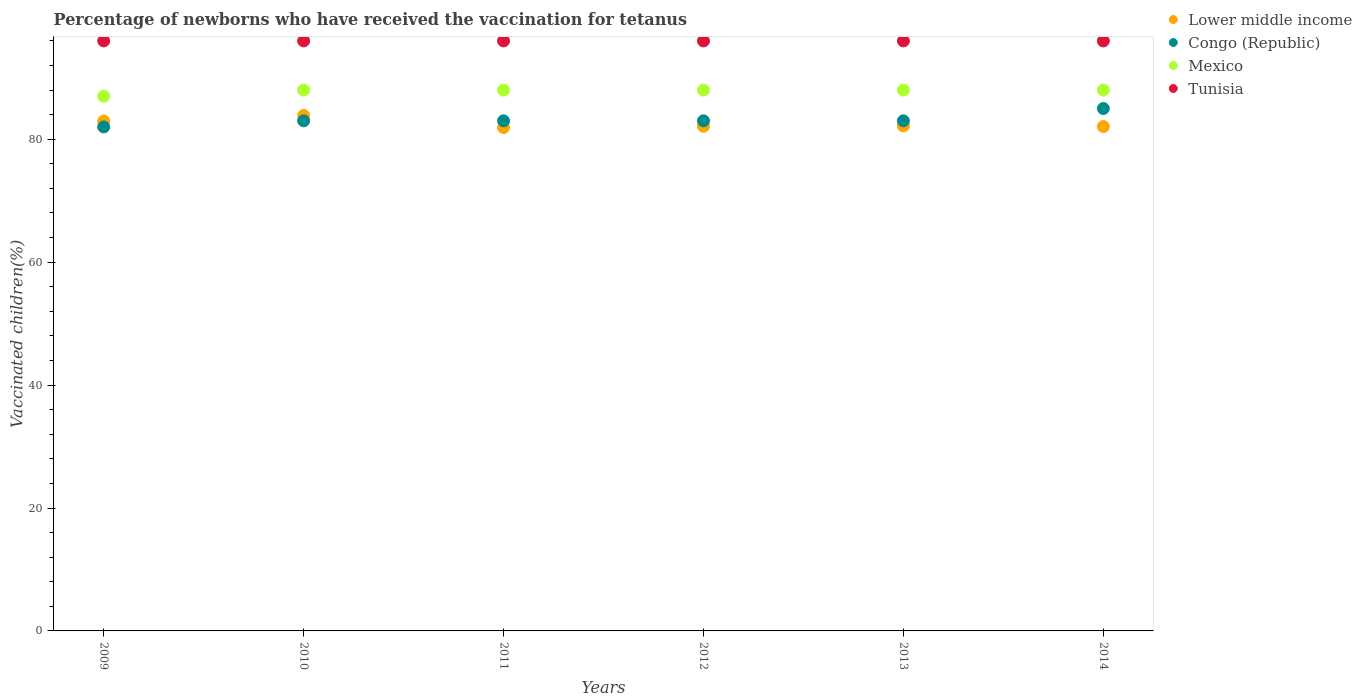What is the percentage of vaccinated children in Mexico in 2014?
Provide a short and direct response. 88. Across all years, what is the maximum percentage of vaccinated children in Mexico?
Ensure brevity in your answer.  88. In which year was the percentage of vaccinated children in Tunisia maximum?
Offer a very short reply. 2009. In which year was the percentage of vaccinated children in Mexico minimum?
Your answer should be very brief. 2009. What is the total percentage of vaccinated children in Congo (Republic) in the graph?
Offer a terse response. 499. What is the difference between the percentage of vaccinated children in Mexico in 2013 and that in 2014?
Provide a short and direct response. 0. What is the average percentage of vaccinated children in Congo (Republic) per year?
Make the answer very short. 83.17. In how many years, is the percentage of vaccinated children in Lower middle income greater than 92 %?
Offer a terse response. 0. What is the ratio of the percentage of vaccinated children in Lower middle income in 2010 to that in 2012?
Your response must be concise. 1.02. Is the difference between the percentage of vaccinated children in Tunisia in 2011 and 2013 greater than the difference between the percentage of vaccinated children in Congo (Republic) in 2011 and 2013?
Provide a short and direct response. No. In how many years, is the percentage of vaccinated children in Tunisia greater than the average percentage of vaccinated children in Tunisia taken over all years?
Your answer should be compact. 0. Is it the case that in every year, the sum of the percentage of vaccinated children in Mexico and percentage of vaccinated children in Congo (Republic)  is greater than the sum of percentage of vaccinated children in Tunisia and percentage of vaccinated children in Lower middle income?
Offer a terse response. Yes. Is it the case that in every year, the sum of the percentage of vaccinated children in Lower middle income and percentage of vaccinated children in Congo (Republic)  is greater than the percentage of vaccinated children in Mexico?
Keep it short and to the point. Yes. Does the percentage of vaccinated children in Congo (Republic) monotonically increase over the years?
Ensure brevity in your answer.  No. Is the percentage of vaccinated children in Mexico strictly less than the percentage of vaccinated children in Tunisia over the years?
Your answer should be compact. Yes. How many years are there in the graph?
Offer a very short reply. 6. How many legend labels are there?
Give a very brief answer. 4. What is the title of the graph?
Offer a very short reply. Percentage of newborns who have received the vaccination for tetanus. Does "Middle income" appear as one of the legend labels in the graph?
Offer a very short reply. No. What is the label or title of the Y-axis?
Make the answer very short. Vaccinated children(%). What is the Vaccinated children(%) in Lower middle income in 2009?
Keep it short and to the point. 82.96. What is the Vaccinated children(%) in Mexico in 2009?
Give a very brief answer. 87. What is the Vaccinated children(%) of Tunisia in 2009?
Provide a succinct answer. 96. What is the Vaccinated children(%) of Lower middle income in 2010?
Your response must be concise. 83.87. What is the Vaccinated children(%) in Congo (Republic) in 2010?
Offer a very short reply. 83. What is the Vaccinated children(%) of Tunisia in 2010?
Offer a terse response. 96. What is the Vaccinated children(%) in Lower middle income in 2011?
Keep it short and to the point. 81.9. What is the Vaccinated children(%) in Congo (Republic) in 2011?
Your response must be concise. 83. What is the Vaccinated children(%) in Mexico in 2011?
Ensure brevity in your answer.  88. What is the Vaccinated children(%) in Tunisia in 2011?
Make the answer very short. 96. What is the Vaccinated children(%) in Lower middle income in 2012?
Ensure brevity in your answer.  82.12. What is the Vaccinated children(%) in Congo (Republic) in 2012?
Your response must be concise. 83. What is the Vaccinated children(%) of Tunisia in 2012?
Offer a terse response. 96. What is the Vaccinated children(%) of Lower middle income in 2013?
Offer a terse response. 82.17. What is the Vaccinated children(%) in Congo (Republic) in 2013?
Offer a very short reply. 83. What is the Vaccinated children(%) in Mexico in 2013?
Your answer should be compact. 88. What is the Vaccinated children(%) of Tunisia in 2013?
Your response must be concise. 96. What is the Vaccinated children(%) of Lower middle income in 2014?
Give a very brief answer. 82.06. What is the Vaccinated children(%) of Congo (Republic) in 2014?
Provide a succinct answer. 85. What is the Vaccinated children(%) of Mexico in 2014?
Your response must be concise. 88. What is the Vaccinated children(%) in Tunisia in 2014?
Your answer should be compact. 96. Across all years, what is the maximum Vaccinated children(%) of Lower middle income?
Offer a terse response. 83.87. Across all years, what is the maximum Vaccinated children(%) of Mexico?
Make the answer very short. 88. Across all years, what is the maximum Vaccinated children(%) of Tunisia?
Offer a very short reply. 96. Across all years, what is the minimum Vaccinated children(%) in Lower middle income?
Offer a terse response. 81.9. Across all years, what is the minimum Vaccinated children(%) of Congo (Republic)?
Offer a terse response. 82. Across all years, what is the minimum Vaccinated children(%) in Mexico?
Offer a terse response. 87. Across all years, what is the minimum Vaccinated children(%) in Tunisia?
Your response must be concise. 96. What is the total Vaccinated children(%) in Lower middle income in the graph?
Keep it short and to the point. 495.07. What is the total Vaccinated children(%) in Congo (Republic) in the graph?
Keep it short and to the point. 499. What is the total Vaccinated children(%) in Mexico in the graph?
Give a very brief answer. 527. What is the total Vaccinated children(%) of Tunisia in the graph?
Your answer should be compact. 576. What is the difference between the Vaccinated children(%) of Lower middle income in 2009 and that in 2010?
Offer a terse response. -0.91. What is the difference between the Vaccinated children(%) in Mexico in 2009 and that in 2010?
Give a very brief answer. -1. What is the difference between the Vaccinated children(%) of Tunisia in 2009 and that in 2010?
Your answer should be compact. 0. What is the difference between the Vaccinated children(%) in Lower middle income in 2009 and that in 2011?
Your answer should be compact. 1.06. What is the difference between the Vaccinated children(%) of Lower middle income in 2009 and that in 2012?
Make the answer very short. 0.84. What is the difference between the Vaccinated children(%) of Congo (Republic) in 2009 and that in 2012?
Provide a succinct answer. -1. What is the difference between the Vaccinated children(%) of Tunisia in 2009 and that in 2012?
Provide a succinct answer. 0. What is the difference between the Vaccinated children(%) of Lower middle income in 2009 and that in 2013?
Offer a terse response. 0.79. What is the difference between the Vaccinated children(%) of Mexico in 2009 and that in 2013?
Give a very brief answer. -1. What is the difference between the Vaccinated children(%) in Tunisia in 2009 and that in 2013?
Make the answer very short. 0. What is the difference between the Vaccinated children(%) of Lower middle income in 2009 and that in 2014?
Provide a succinct answer. 0.89. What is the difference between the Vaccinated children(%) in Mexico in 2009 and that in 2014?
Keep it short and to the point. -1. What is the difference between the Vaccinated children(%) in Tunisia in 2009 and that in 2014?
Your answer should be compact. 0. What is the difference between the Vaccinated children(%) in Lower middle income in 2010 and that in 2011?
Your answer should be compact. 1.97. What is the difference between the Vaccinated children(%) in Tunisia in 2010 and that in 2011?
Your answer should be very brief. 0. What is the difference between the Vaccinated children(%) in Lower middle income in 2010 and that in 2012?
Your response must be concise. 1.75. What is the difference between the Vaccinated children(%) in Tunisia in 2010 and that in 2012?
Ensure brevity in your answer.  0. What is the difference between the Vaccinated children(%) in Lower middle income in 2010 and that in 2013?
Offer a terse response. 1.7. What is the difference between the Vaccinated children(%) in Congo (Republic) in 2010 and that in 2013?
Ensure brevity in your answer.  0. What is the difference between the Vaccinated children(%) of Tunisia in 2010 and that in 2013?
Give a very brief answer. 0. What is the difference between the Vaccinated children(%) of Lower middle income in 2010 and that in 2014?
Provide a short and direct response. 1.8. What is the difference between the Vaccinated children(%) of Congo (Republic) in 2010 and that in 2014?
Your response must be concise. -2. What is the difference between the Vaccinated children(%) in Lower middle income in 2011 and that in 2012?
Your response must be concise. -0.22. What is the difference between the Vaccinated children(%) of Tunisia in 2011 and that in 2012?
Keep it short and to the point. 0. What is the difference between the Vaccinated children(%) of Lower middle income in 2011 and that in 2013?
Keep it short and to the point. -0.27. What is the difference between the Vaccinated children(%) of Mexico in 2011 and that in 2013?
Your response must be concise. 0. What is the difference between the Vaccinated children(%) of Tunisia in 2011 and that in 2013?
Offer a terse response. 0. What is the difference between the Vaccinated children(%) in Lower middle income in 2011 and that in 2014?
Offer a very short reply. -0.16. What is the difference between the Vaccinated children(%) of Lower middle income in 2012 and that in 2013?
Ensure brevity in your answer.  -0.05. What is the difference between the Vaccinated children(%) in Mexico in 2012 and that in 2013?
Offer a very short reply. 0. What is the difference between the Vaccinated children(%) of Lower middle income in 2012 and that in 2014?
Offer a very short reply. 0.05. What is the difference between the Vaccinated children(%) of Congo (Republic) in 2012 and that in 2014?
Your answer should be compact. -2. What is the difference between the Vaccinated children(%) in Mexico in 2012 and that in 2014?
Ensure brevity in your answer.  0. What is the difference between the Vaccinated children(%) in Lower middle income in 2013 and that in 2014?
Offer a very short reply. 0.1. What is the difference between the Vaccinated children(%) of Tunisia in 2013 and that in 2014?
Make the answer very short. 0. What is the difference between the Vaccinated children(%) of Lower middle income in 2009 and the Vaccinated children(%) of Congo (Republic) in 2010?
Offer a terse response. -0.04. What is the difference between the Vaccinated children(%) in Lower middle income in 2009 and the Vaccinated children(%) in Mexico in 2010?
Make the answer very short. -5.04. What is the difference between the Vaccinated children(%) of Lower middle income in 2009 and the Vaccinated children(%) of Tunisia in 2010?
Provide a short and direct response. -13.04. What is the difference between the Vaccinated children(%) in Congo (Republic) in 2009 and the Vaccinated children(%) in Tunisia in 2010?
Offer a very short reply. -14. What is the difference between the Vaccinated children(%) of Mexico in 2009 and the Vaccinated children(%) of Tunisia in 2010?
Give a very brief answer. -9. What is the difference between the Vaccinated children(%) of Lower middle income in 2009 and the Vaccinated children(%) of Congo (Republic) in 2011?
Offer a very short reply. -0.04. What is the difference between the Vaccinated children(%) of Lower middle income in 2009 and the Vaccinated children(%) of Mexico in 2011?
Your response must be concise. -5.04. What is the difference between the Vaccinated children(%) in Lower middle income in 2009 and the Vaccinated children(%) in Tunisia in 2011?
Offer a very short reply. -13.04. What is the difference between the Vaccinated children(%) of Congo (Republic) in 2009 and the Vaccinated children(%) of Tunisia in 2011?
Your answer should be very brief. -14. What is the difference between the Vaccinated children(%) in Lower middle income in 2009 and the Vaccinated children(%) in Congo (Republic) in 2012?
Your response must be concise. -0.04. What is the difference between the Vaccinated children(%) in Lower middle income in 2009 and the Vaccinated children(%) in Mexico in 2012?
Offer a very short reply. -5.04. What is the difference between the Vaccinated children(%) in Lower middle income in 2009 and the Vaccinated children(%) in Tunisia in 2012?
Offer a very short reply. -13.04. What is the difference between the Vaccinated children(%) in Congo (Republic) in 2009 and the Vaccinated children(%) in Mexico in 2012?
Ensure brevity in your answer.  -6. What is the difference between the Vaccinated children(%) of Lower middle income in 2009 and the Vaccinated children(%) of Congo (Republic) in 2013?
Offer a very short reply. -0.04. What is the difference between the Vaccinated children(%) of Lower middle income in 2009 and the Vaccinated children(%) of Mexico in 2013?
Offer a terse response. -5.04. What is the difference between the Vaccinated children(%) in Lower middle income in 2009 and the Vaccinated children(%) in Tunisia in 2013?
Keep it short and to the point. -13.04. What is the difference between the Vaccinated children(%) of Mexico in 2009 and the Vaccinated children(%) of Tunisia in 2013?
Make the answer very short. -9. What is the difference between the Vaccinated children(%) of Lower middle income in 2009 and the Vaccinated children(%) of Congo (Republic) in 2014?
Offer a very short reply. -2.04. What is the difference between the Vaccinated children(%) of Lower middle income in 2009 and the Vaccinated children(%) of Mexico in 2014?
Provide a short and direct response. -5.04. What is the difference between the Vaccinated children(%) in Lower middle income in 2009 and the Vaccinated children(%) in Tunisia in 2014?
Offer a very short reply. -13.04. What is the difference between the Vaccinated children(%) in Congo (Republic) in 2009 and the Vaccinated children(%) in Tunisia in 2014?
Your answer should be compact. -14. What is the difference between the Vaccinated children(%) of Mexico in 2009 and the Vaccinated children(%) of Tunisia in 2014?
Keep it short and to the point. -9. What is the difference between the Vaccinated children(%) in Lower middle income in 2010 and the Vaccinated children(%) in Congo (Republic) in 2011?
Your response must be concise. 0.87. What is the difference between the Vaccinated children(%) in Lower middle income in 2010 and the Vaccinated children(%) in Mexico in 2011?
Your answer should be very brief. -4.13. What is the difference between the Vaccinated children(%) of Lower middle income in 2010 and the Vaccinated children(%) of Tunisia in 2011?
Your response must be concise. -12.13. What is the difference between the Vaccinated children(%) in Congo (Republic) in 2010 and the Vaccinated children(%) in Mexico in 2011?
Provide a short and direct response. -5. What is the difference between the Vaccinated children(%) in Mexico in 2010 and the Vaccinated children(%) in Tunisia in 2011?
Keep it short and to the point. -8. What is the difference between the Vaccinated children(%) in Lower middle income in 2010 and the Vaccinated children(%) in Congo (Republic) in 2012?
Provide a short and direct response. 0.87. What is the difference between the Vaccinated children(%) of Lower middle income in 2010 and the Vaccinated children(%) of Mexico in 2012?
Ensure brevity in your answer.  -4.13. What is the difference between the Vaccinated children(%) of Lower middle income in 2010 and the Vaccinated children(%) of Tunisia in 2012?
Your response must be concise. -12.13. What is the difference between the Vaccinated children(%) of Congo (Republic) in 2010 and the Vaccinated children(%) of Mexico in 2012?
Provide a succinct answer. -5. What is the difference between the Vaccinated children(%) of Lower middle income in 2010 and the Vaccinated children(%) of Congo (Republic) in 2013?
Provide a short and direct response. 0.87. What is the difference between the Vaccinated children(%) of Lower middle income in 2010 and the Vaccinated children(%) of Mexico in 2013?
Offer a terse response. -4.13. What is the difference between the Vaccinated children(%) in Lower middle income in 2010 and the Vaccinated children(%) in Tunisia in 2013?
Your answer should be very brief. -12.13. What is the difference between the Vaccinated children(%) of Congo (Republic) in 2010 and the Vaccinated children(%) of Mexico in 2013?
Provide a short and direct response. -5. What is the difference between the Vaccinated children(%) in Congo (Republic) in 2010 and the Vaccinated children(%) in Tunisia in 2013?
Your answer should be very brief. -13. What is the difference between the Vaccinated children(%) in Lower middle income in 2010 and the Vaccinated children(%) in Congo (Republic) in 2014?
Give a very brief answer. -1.13. What is the difference between the Vaccinated children(%) in Lower middle income in 2010 and the Vaccinated children(%) in Mexico in 2014?
Ensure brevity in your answer.  -4.13. What is the difference between the Vaccinated children(%) of Lower middle income in 2010 and the Vaccinated children(%) of Tunisia in 2014?
Your response must be concise. -12.13. What is the difference between the Vaccinated children(%) of Congo (Republic) in 2010 and the Vaccinated children(%) of Mexico in 2014?
Keep it short and to the point. -5. What is the difference between the Vaccinated children(%) of Mexico in 2010 and the Vaccinated children(%) of Tunisia in 2014?
Ensure brevity in your answer.  -8. What is the difference between the Vaccinated children(%) in Lower middle income in 2011 and the Vaccinated children(%) in Congo (Republic) in 2012?
Give a very brief answer. -1.1. What is the difference between the Vaccinated children(%) of Lower middle income in 2011 and the Vaccinated children(%) of Mexico in 2012?
Provide a succinct answer. -6.1. What is the difference between the Vaccinated children(%) of Lower middle income in 2011 and the Vaccinated children(%) of Tunisia in 2012?
Your response must be concise. -14.1. What is the difference between the Vaccinated children(%) of Congo (Republic) in 2011 and the Vaccinated children(%) of Mexico in 2012?
Provide a succinct answer. -5. What is the difference between the Vaccinated children(%) in Lower middle income in 2011 and the Vaccinated children(%) in Congo (Republic) in 2013?
Provide a short and direct response. -1.1. What is the difference between the Vaccinated children(%) in Lower middle income in 2011 and the Vaccinated children(%) in Mexico in 2013?
Offer a very short reply. -6.1. What is the difference between the Vaccinated children(%) in Lower middle income in 2011 and the Vaccinated children(%) in Tunisia in 2013?
Offer a terse response. -14.1. What is the difference between the Vaccinated children(%) in Congo (Republic) in 2011 and the Vaccinated children(%) in Mexico in 2013?
Your answer should be compact. -5. What is the difference between the Vaccinated children(%) of Congo (Republic) in 2011 and the Vaccinated children(%) of Tunisia in 2013?
Keep it short and to the point. -13. What is the difference between the Vaccinated children(%) of Lower middle income in 2011 and the Vaccinated children(%) of Congo (Republic) in 2014?
Your response must be concise. -3.1. What is the difference between the Vaccinated children(%) in Lower middle income in 2011 and the Vaccinated children(%) in Mexico in 2014?
Offer a terse response. -6.1. What is the difference between the Vaccinated children(%) in Lower middle income in 2011 and the Vaccinated children(%) in Tunisia in 2014?
Offer a terse response. -14.1. What is the difference between the Vaccinated children(%) in Congo (Republic) in 2011 and the Vaccinated children(%) in Tunisia in 2014?
Ensure brevity in your answer.  -13. What is the difference between the Vaccinated children(%) in Mexico in 2011 and the Vaccinated children(%) in Tunisia in 2014?
Offer a very short reply. -8. What is the difference between the Vaccinated children(%) of Lower middle income in 2012 and the Vaccinated children(%) of Congo (Republic) in 2013?
Offer a terse response. -0.88. What is the difference between the Vaccinated children(%) in Lower middle income in 2012 and the Vaccinated children(%) in Mexico in 2013?
Your answer should be very brief. -5.88. What is the difference between the Vaccinated children(%) of Lower middle income in 2012 and the Vaccinated children(%) of Tunisia in 2013?
Your answer should be compact. -13.88. What is the difference between the Vaccinated children(%) in Congo (Republic) in 2012 and the Vaccinated children(%) in Mexico in 2013?
Your response must be concise. -5. What is the difference between the Vaccinated children(%) of Mexico in 2012 and the Vaccinated children(%) of Tunisia in 2013?
Give a very brief answer. -8. What is the difference between the Vaccinated children(%) in Lower middle income in 2012 and the Vaccinated children(%) in Congo (Republic) in 2014?
Provide a short and direct response. -2.88. What is the difference between the Vaccinated children(%) in Lower middle income in 2012 and the Vaccinated children(%) in Mexico in 2014?
Your response must be concise. -5.88. What is the difference between the Vaccinated children(%) of Lower middle income in 2012 and the Vaccinated children(%) of Tunisia in 2014?
Your answer should be compact. -13.88. What is the difference between the Vaccinated children(%) of Congo (Republic) in 2012 and the Vaccinated children(%) of Mexico in 2014?
Your answer should be very brief. -5. What is the difference between the Vaccinated children(%) of Lower middle income in 2013 and the Vaccinated children(%) of Congo (Republic) in 2014?
Your response must be concise. -2.83. What is the difference between the Vaccinated children(%) of Lower middle income in 2013 and the Vaccinated children(%) of Mexico in 2014?
Offer a terse response. -5.83. What is the difference between the Vaccinated children(%) in Lower middle income in 2013 and the Vaccinated children(%) in Tunisia in 2014?
Ensure brevity in your answer.  -13.83. What is the difference between the Vaccinated children(%) of Congo (Republic) in 2013 and the Vaccinated children(%) of Mexico in 2014?
Give a very brief answer. -5. What is the difference between the Vaccinated children(%) of Congo (Republic) in 2013 and the Vaccinated children(%) of Tunisia in 2014?
Your response must be concise. -13. What is the average Vaccinated children(%) of Lower middle income per year?
Make the answer very short. 82.51. What is the average Vaccinated children(%) in Congo (Republic) per year?
Give a very brief answer. 83.17. What is the average Vaccinated children(%) of Mexico per year?
Offer a terse response. 87.83. What is the average Vaccinated children(%) of Tunisia per year?
Provide a succinct answer. 96. In the year 2009, what is the difference between the Vaccinated children(%) in Lower middle income and Vaccinated children(%) in Congo (Republic)?
Provide a succinct answer. 0.96. In the year 2009, what is the difference between the Vaccinated children(%) in Lower middle income and Vaccinated children(%) in Mexico?
Give a very brief answer. -4.04. In the year 2009, what is the difference between the Vaccinated children(%) in Lower middle income and Vaccinated children(%) in Tunisia?
Your response must be concise. -13.04. In the year 2009, what is the difference between the Vaccinated children(%) of Congo (Republic) and Vaccinated children(%) of Tunisia?
Provide a succinct answer. -14. In the year 2010, what is the difference between the Vaccinated children(%) in Lower middle income and Vaccinated children(%) in Congo (Republic)?
Provide a short and direct response. 0.87. In the year 2010, what is the difference between the Vaccinated children(%) in Lower middle income and Vaccinated children(%) in Mexico?
Provide a short and direct response. -4.13. In the year 2010, what is the difference between the Vaccinated children(%) in Lower middle income and Vaccinated children(%) in Tunisia?
Provide a succinct answer. -12.13. In the year 2010, what is the difference between the Vaccinated children(%) in Congo (Republic) and Vaccinated children(%) in Tunisia?
Make the answer very short. -13. In the year 2010, what is the difference between the Vaccinated children(%) in Mexico and Vaccinated children(%) in Tunisia?
Ensure brevity in your answer.  -8. In the year 2011, what is the difference between the Vaccinated children(%) in Lower middle income and Vaccinated children(%) in Congo (Republic)?
Provide a short and direct response. -1.1. In the year 2011, what is the difference between the Vaccinated children(%) of Lower middle income and Vaccinated children(%) of Mexico?
Keep it short and to the point. -6.1. In the year 2011, what is the difference between the Vaccinated children(%) in Lower middle income and Vaccinated children(%) in Tunisia?
Give a very brief answer. -14.1. In the year 2011, what is the difference between the Vaccinated children(%) in Congo (Republic) and Vaccinated children(%) in Mexico?
Give a very brief answer. -5. In the year 2011, what is the difference between the Vaccinated children(%) in Mexico and Vaccinated children(%) in Tunisia?
Provide a short and direct response. -8. In the year 2012, what is the difference between the Vaccinated children(%) of Lower middle income and Vaccinated children(%) of Congo (Republic)?
Provide a succinct answer. -0.88. In the year 2012, what is the difference between the Vaccinated children(%) of Lower middle income and Vaccinated children(%) of Mexico?
Ensure brevity in your answer.  -5.88. In the year 2012, what is the difference between the Vaccinated children(%) of Lower middle income and Vaccinated children(%) of Tunisia?
Provide a short and direct response. -13.88. In the year 2012, what is the difference between the Vaccinated children(%) in Mexico and Vaccinated children(%) in Tunisia?
Your answer should be compact. -8. In the year 2013, what is the difference between the Vaccinated children(%) of Lower middle income and Vaccinated children(%) of Congo (Republic)?
Your answer should be very brief. -0.83. In the year 2013, what is the difference between the Vaccinated children(%) of Lower middle income and Vaccinated children(%) of Mexico?
Make the answer very short. -5.83. In the year 2013, what is the difference between the Vaccinated children(%) of Lower middle income and Vaccinated children(%) of Tunisia?
Provide a short and direct response. -13.83. In the year 2014, what is the difference between the Vaccinated children(%) in Lower middle income and Vaccinated children(%) in Congo (Republic)?
Your response must be concise. -2.94. In the year 2014, what is the difference between the Vaccinated children(%) in Lower middle income and Vaccinated children(%) in Mexico?
Provide a succinct answer. -5.94. In the year 2014, what is the difference between the Vaccinated children(%) in Lower middle income and Vaccinated children(%) in Tunisia?
Provide a succinct answer. -13.94. In the year 2014, what is the difference between the Vaccinated children(%) in Congo (Republic) and Vaccinated children(%) in Mexico?
Your answer should be very brief. -3. In the year 2014, what is the difference between the Vaccinated children(%) in Congo (Republic) and Vaccinated children(%) in Tunisia?
Provide a short and direct response. -11. What is the ratio of the Vaccinated children(%) of Tunisia in 2009 to that in 2010?
Keep it short and to the point. 1. What is the ratio of the Vaccinated children(%) of Lower middle income in 2009 to that in 2011?
Ensure brevity in your answer.  1.01. What is the ratio of the Vaccinated children(%) in Congo (Republic) in 2009 to that in 2011?
Ensure brevity in your answer.  0.99. What is the ratio of the Vaccinated children(%) in Tunisia in 2009 to that in 2011?
Your response must be concise. 1. What is the ratio of the Vaccinated children(%) of Lower middle income in 2009 to that in 2012?
Keep it short and to the point. 1.01. What is the ratio of the Vaccinated children(%) in Congo (Republic) in 2009 to that in 2012?
Your answer should be very brief. 0.99. What is the ratio of the Vaccinated children(%) in Tunisia in 2009 to that in 2012?
Offer a terse response. 1. What is the ratio of the Vaccinated children(%) in Lower middle income in 2009 to that in 2013?
Offer a very short reply. 1.01. What is the ratio of the Vaccinated children(%) of Congo (Republic) in 2009 to that in 2013?
Your response must be concise. 0.99. What is the ratio of the Vaccinated children(%) in Tunisia in 2009 to that in 2013?
Your answer should be compact. 1. What is the ratio of the Vaccinated children(%) of Lower middle income in 2009 to that in 2014?
Keep it short and to the point. 1.01. What is the ratio of the Vaccinated children(%) of Congo (Republic) in 2009 to that in 2014?
Your answer should be compact. 0.96. What is the ratio of the Vaccinated children(%) in Mexico in 2009 to that in 2014?
Your response must be concise. 0.99. What is the ratio of the Vaccinated children(%) of Congo (Republic) in 2010 to that in 2011?
Keep it short and to the point. 1. What is the ratio of the Vaccinated children(%) of Lower middle income in 2010 to that in 2012?
Your answer should be very brief. 1.02. What is the ratio of the Vaccinated children(%) of Mexico in 2010 to that in 2012?
Your answer should be very brief. 1. What is the ratio of the Vaccinated children(%) of Tunisia in 2010 to that in 2012?
Keep it short and to the point. 1. What is the ratio of the Vaccinated children(%) of Lower middle income in 2010 to that in 2013?
Provide a succinct answer. 1.02. What is the ratio of the Vaccinated children(%) in Lower middle income in 2010 to that in 2014?
Offer a very short reply. 1.02. What is the ratio of the Vaccinated children(%) of Congo (Republic) in 2010 to that in 2014?
Your answer should be very brief. 0.98. What is the ratio of the Vaccinated children(%) in Mexico in 2010 to that in 2014?
Give a very brief answer. 1. What is the ratio of the Vaccinated children(%) in Tunisia in 2010 to that in 2014?
Provide a succinct answer. 1. What is the ratio of the Vaccinated children(%) of Lower middle income in 2011 to that in 2012?
Give a very brief answer. 1. What is the ratio of the Vaccinated children(%) of Congo (Republic) in 2011 to that in 2012?
Make the answer very short. 1. What is the ratio of the Vaccinated children(%) in Mexico in 2011 to that in 2012?
Your response must be concise. 1. What is the ratio of the Vaccinated children(%) of Lower middle income in 2011 to that in 2013?
Your answer should be very brief. 1. What is the ratio of the Vaccinated children(%) in Congo (Republic) in 2011 to that in 2013?
Offer a very short reply. 1. What is the ratio of the Vaccinated children(%) of Congo (Republic) in 2011 to that in 2014?
Offer a terse response. 0.98. What is the ratio of the Vaccinated children(%) in Mexico in 2012 to that in 2013?
Keep it short and to the point. 1. What is the ratio of the Vaccinated children(%) in Tunisia in 2012 to that in 2013?
Keep it short and to the point. 1. What is the ratio of the Vaccinated children(%) in Congo (Republic) in 2012 to that in 2014?
Your response must be concise. 0.98. What is the ratio of the Vaccinated children(%) in Congo (Republic) in 2013 to that in 2014?
Offer a very short reply. 0.98. What is the ratio of the Vaccinated children(%) of Mexico in 2013 to that in 2014?
Give a very brief answer. 1. What is the ratio of the Vaccinated children(%) in Tunisia in 2013 to that in 2014?
Make the answer very short. 1. What is the difference between the highest and the second highest Vaccinated children(%) in Lower middle income?
Your answer should be very brief. 0.91. What is the difference between the highest and the second highest Vaccinated children(%) of Mexico?
Offer a very short reply. 0. What is the difference between the highest and the lowest Vaccinated children(%) in Lower middle income?
Ensure brevity in your answer.  1.97. What is the difference between the highest and the lowest Vaccinated children(%) in Mexico?
Keep it short and to the point. 1. 